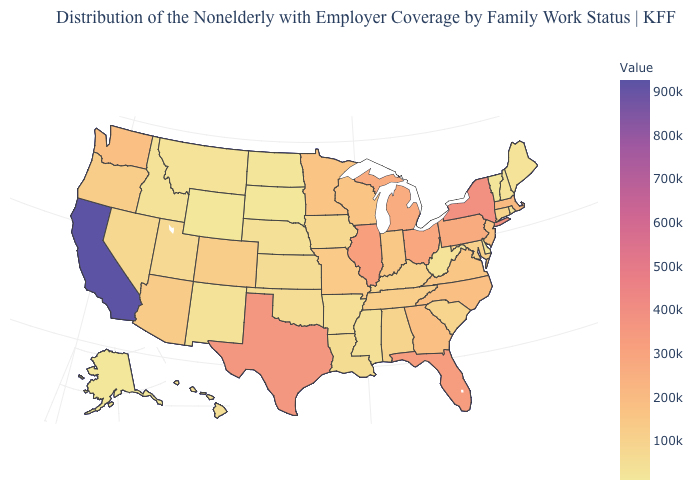Does California have the highest value in the West?
Concise answer only. Yes. Is the legend a continuous bar?
Be succinct. Yes. Among the states that border Maryland , does Delaware have the lowest value?
Give a very brief answer. Yes. Which states have the lowest value in the West?
Write a very short answer. Wyoming. Does Wyoming have the lowest value in the USA?
Write a very short answer. Yes. Is the legend a continuous bar?
Concise answer only. Yes. Which states have the highest value in the USA?
Give a very brief answer. California. Does New York have the lowest value in the USA?
Give a very brief answer. No. Is the legend a continuous bar?
Quick response, please. Yes. 